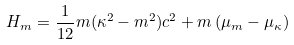<formula> <loc_0><loc_0><loc_500><loc_500>H _ { m } = \frac { 1 } { 1 2 } m ( \kappa ^ { 2 } - m ^ { 2 } ) c ^ { 2 } + m \left ( \mu _ { m } - \mu _ { \kappa } \right )</formula> 